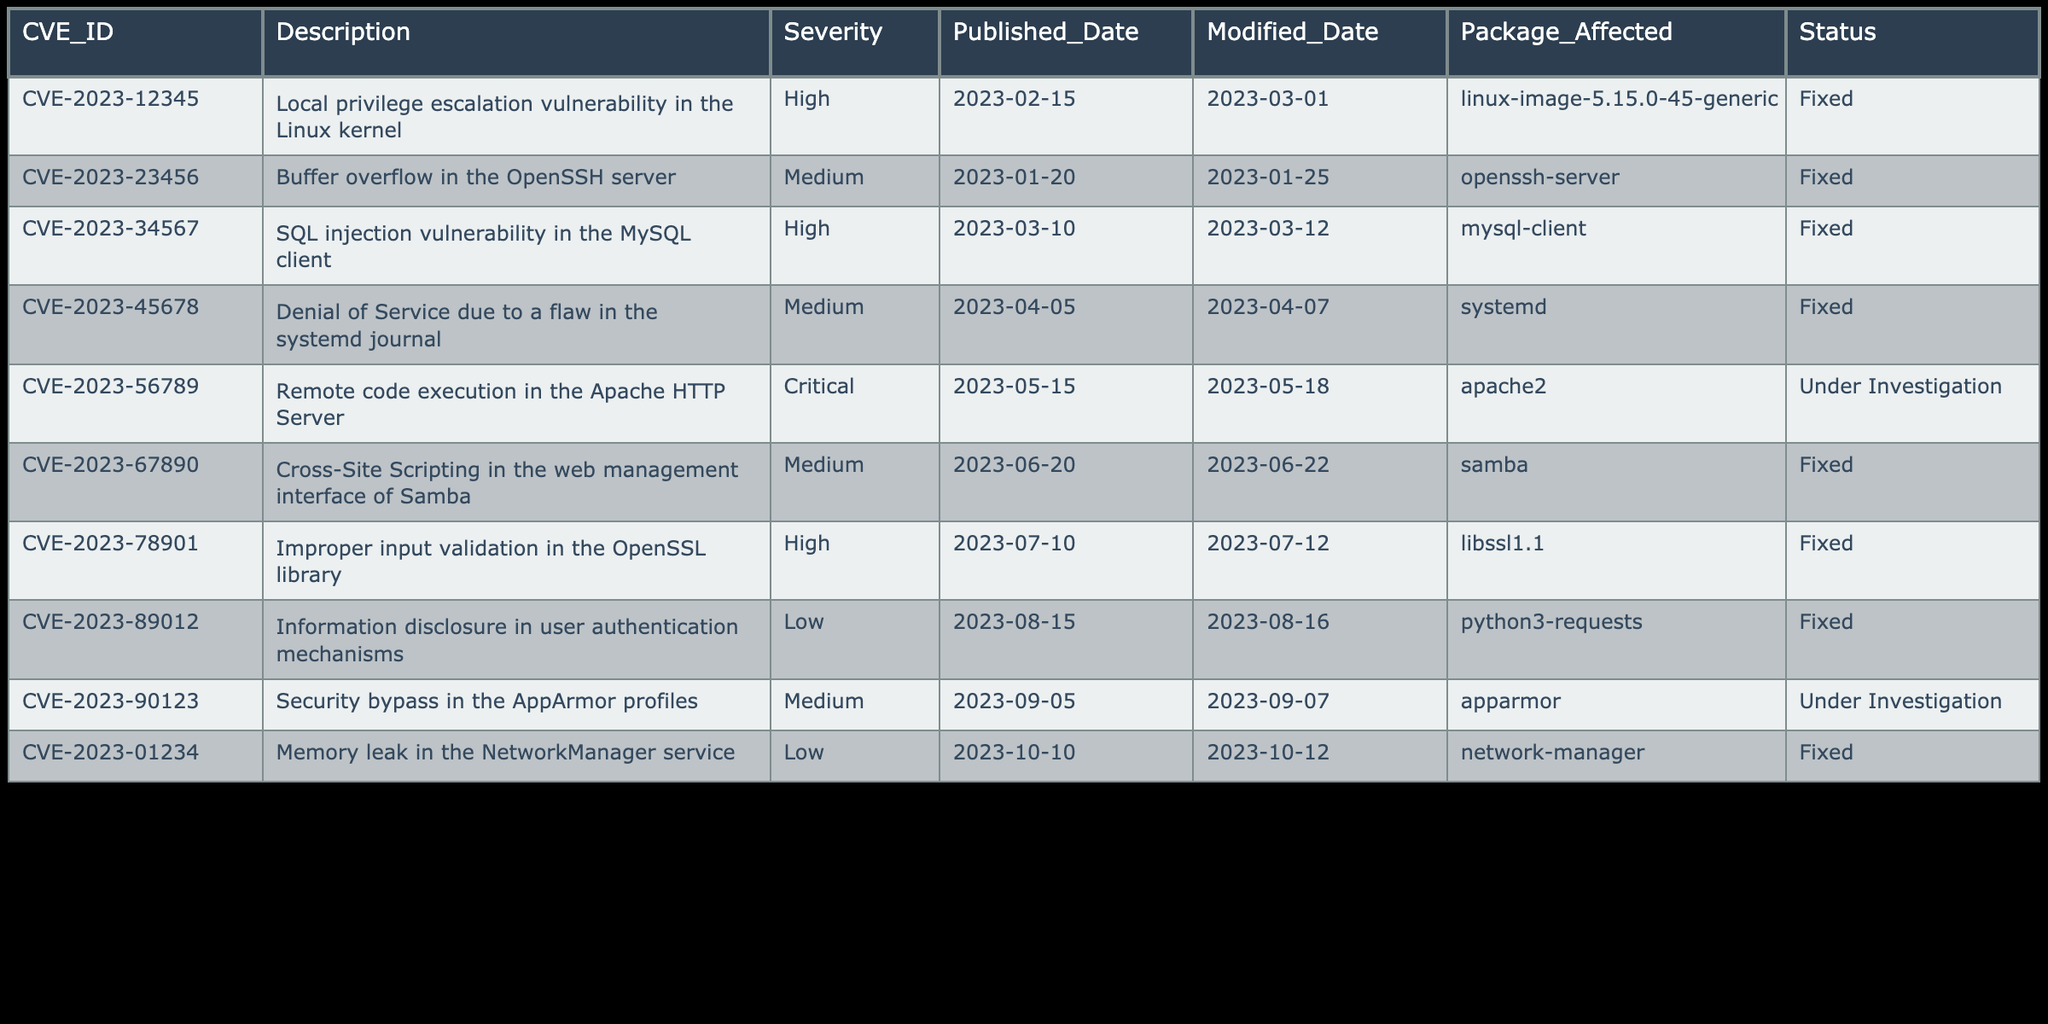What is the CVE ID of the highest severity vulnerability listed? The highest severity vulnerability in the table is marked as "Critical". There is only one entry with a critical severity, which is CVE-2023-56789.
Answer: CVE-2023-56789 How many vulnerabilities have a status of "Under Investigation"? To find this, count the entries in the "Status" column that have "Under Investigation". There are two entries: CVE-2023-56789 and CVE-2023-90123.
Answer: 2 What is the average severity of all vulnerabilities listed? Assign values to severity: High=3, Medium=2, Low=1, Critical=4. Calculate total severity: 3 (High) + 2 (Medium) + 3 (High) + 2 (Medium) + 4 (Critical) + 2 (Medium) + 3 (High) + 1 (Low) + 2 (Medium) + 1 (Low) = 23. There are 10 vulnerabilities, so average = 23/10 = 2.3 (Medium).
Answer: Medium Has any vulnerability affecting "apache2" been reported? Looking at the "Package Affected" column, there is an entry for "apache2" which is CVE-2023-56789, indicating a vulnerability has been reported for this package.
Answer: Yes Which vulnerability was published on March 10, 2023? Search through the "Published_Date" column for the date "2023-03-10." The entry corresponding to this date is CVE-2023-34567.
Answer: CVE-2023-34567 Are there any vulnerabilities that have not been fixed as of the latest update? Review the "Status" column for entries that are not marked as "Fixed". There are two entries that are "Under Investigation", thus indicating there are vulnerabilities not fixed yet.
Answer: Yes What are the affected packages for vulnerabilities with the highest severity? Filter the table for vulnerabilities categorized as "High" or "Critical". The affected packages are: linux-image-5.15.0-45-generic, mysql-client, libssl1.1 for High; apache2 for Critical.
Answer: linux-image-5.15.0-45-generic, mysql-client, libssl1.1, apache2 What was the latest published date for vulnerabilities listed? The latest published date is found by checking the "Published_Date" column for the maximum date. The latest published date is 2023-10-10 for CVE-2023-01234.
Answer: 2023-10-10 How many vulnerabilities involve low severity issues? Count the entries in the "Severity" column that are labeled as "Low". The entries with low severity are CVE-2023-89012 and CVE-2023-01234, resulting in a total count of 2.
Answer: 2 